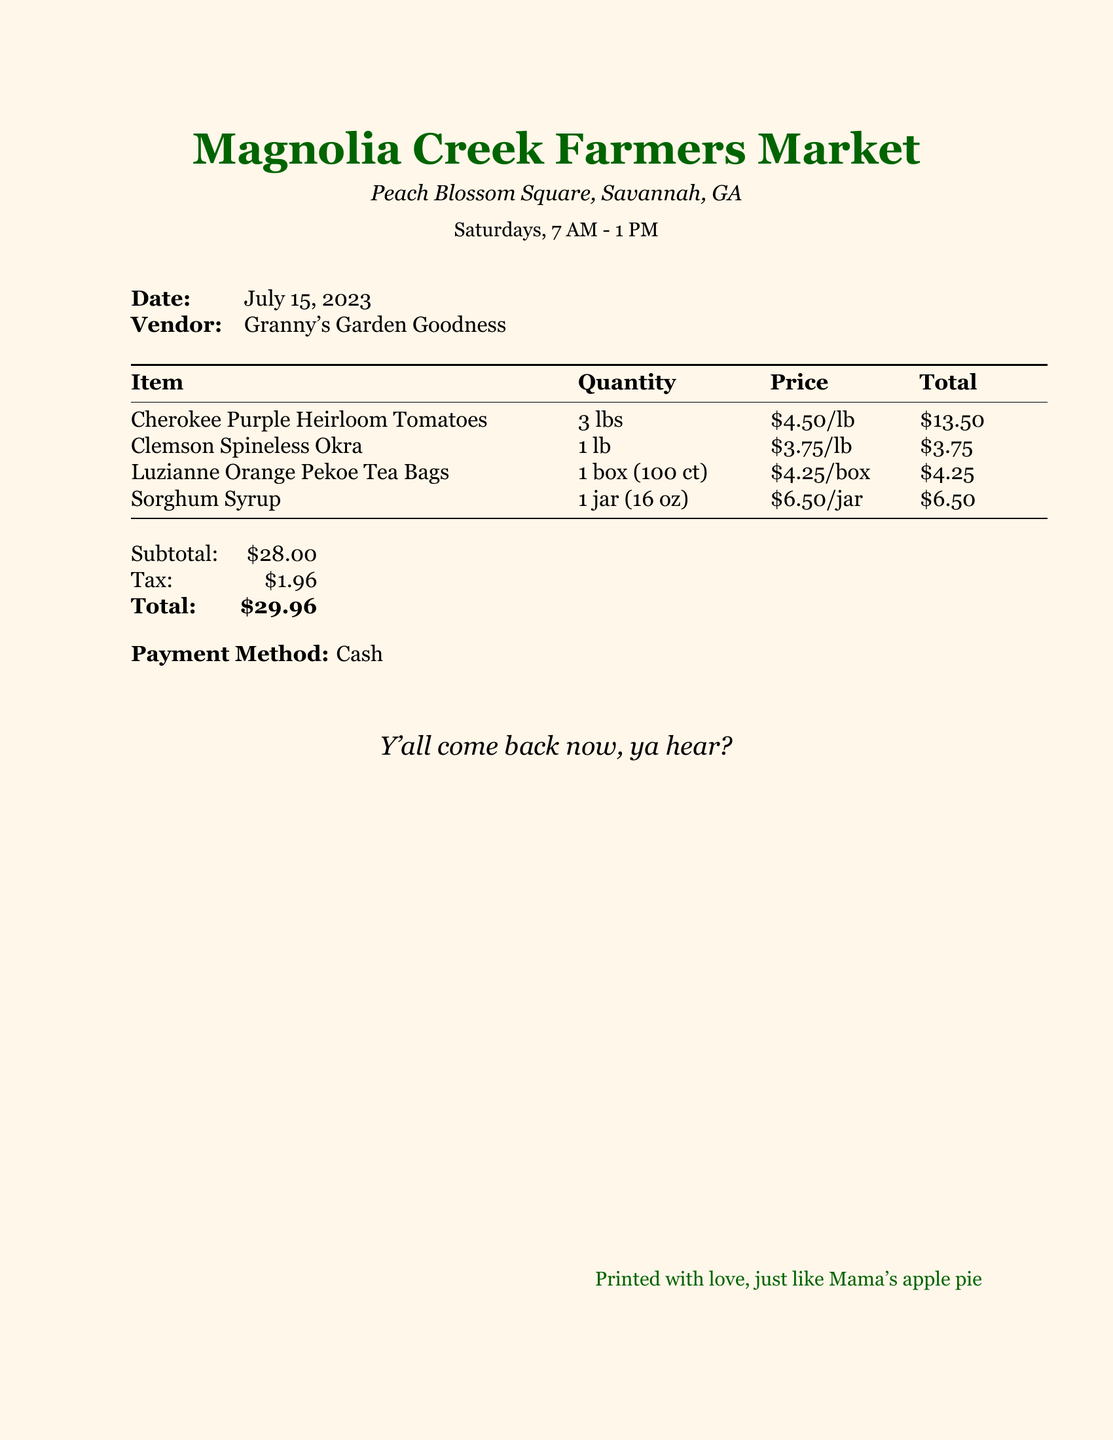What is the date of the receipt? The date of the receipt can be found at the top of the document.
Answer: July 15, 2023 Who is the vendor of the items? The vendor name is listed right below the date.
Answer: Granny's Garden Goodness How much did the heirloom tomatoes cost per pound? The price per pound for the heirloom tomatoes is mentioned in the itemized list.
Answer: $4.50/lb What is the total amount after tax? The total amount is summarized at the bottom of the document after calculating subtotal and tax.
Answer: $29.96 What type of tea bags were purchased? The type of tea bags is listed in the items section.
Answer: Luzianne Orange Pekoe Tea Bags How many pounds of okra were bought? The quantity of okra is specified in the itemized list.
Answer: 1 lb What is the subtotal before tax? The subtotal is shown just before the tax calculation at the bottom.
Answer: $28.00 What payment method was used? The payment method is mentioned toward the end of the document.
Answer: Cash What is the significance of "y'all come back now, ya hear?" This phrase reflects Southern hospitality and charm that characterizes the market's atmosphere.
Answer: Southern hospitality 